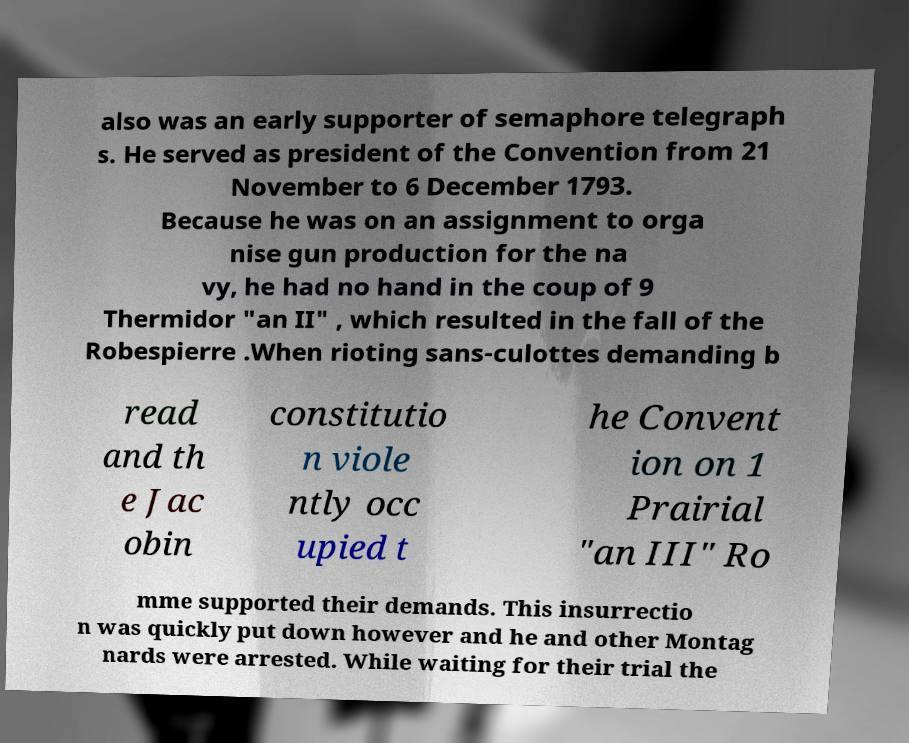There's text embedded in this image that I need extracted. Can you transcribe it verbatim? also was an early supporter of semaphore telegraph s. He served as president of the Convention from 21 November to 6 December 1793. Because he was on an assignment to orga nise gun production for the na vy, he had no hand in the coup of 9 Thermidor "an II" , which resulted in the fall of the Robespierre .When rioting sans-culottes demanding b read and th e Jac obin constitutio n viole ntly occ upied t he Convent ion on 1 Prairial "an III" Ro mme supported their demands. This insurrectio n was quickly put down however and he and other Montag nards were arrested. While waiting for their trial the 